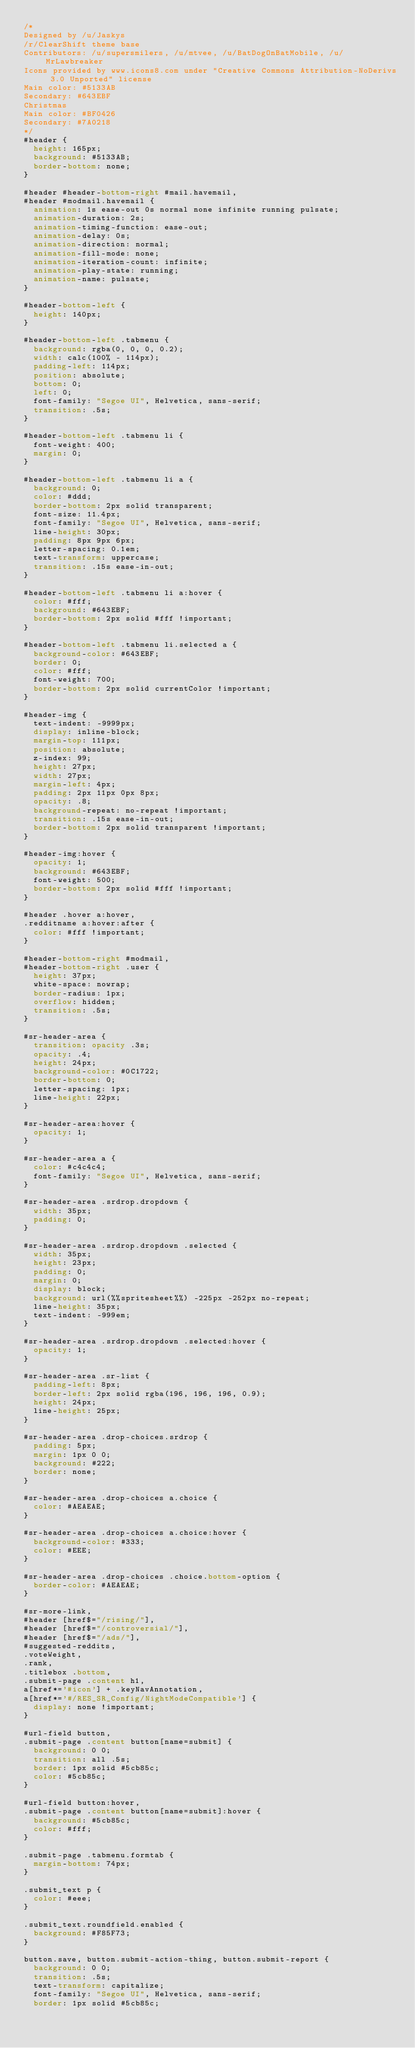Convert code to text. <code><loc_0><loc_0><loc_500><loc_500><_CSS_>/* 
Designed by /u/Jaskys
/r/ClearShift theme base
Contributors: /u/supersmilers, /u/mtvee, /u/BatDogOnBatMobile, /u/MrLawbreaker
Icons provided by www.icons8.com under "Creative Commons Attribution-NoDerivs 3.0 Unported" license
Main color: #5133AB
Secondary: #643EBF
Christmas
Main color: #BF0426
Secondary: #7A0218
*/
#header {
  height: 165px;
  background: #5133AB;
  border-bottom: none;
}

#header #header-bottom-right #mail.havemail,
#header #modmail.havemail {
  animation: 1s ease-out 0s normal none infinite running pulsate;
  animation-duration: 2s;
  animation-timing-function: ease-out;
  animation-delay: 0s;
  animation-direction: normal;
  animation-fill-mode: none;
  animation-iteration-count: infinite;
  animation-play-state: running;
  animation-name: pulsate;
}

#header-bottom-left {
  height: 140px;
}

#header-bottom-left .tabmenu {
  background: rgba(0, 0, 0, 0.2);
  width: calc(100% - 114px);
  padding-left: 114px;
  position: absolute;
  bottom: 0;
  left: 0;
  font-family: "Segoe UI", Helvetica, sans-serif;
  transition: .5s;
}

#header-bottom-left .tabmenu li {
  font-weight: 400;
  margin: 0;
}

#header-bottom-left .tabmenu li a {
  background: 0;
  color: #ddd;
  border-bottom: 2px solid transparent;
  font-size: 11.4px;
  font-family: "Segoe UI", Helvetica, sans-serif;
  line-height: 30px;
  padding: 8px 9px 6px;
  letter-spacing: 0.1em;
  text-transform: uppercase;
  transition: .15s ease-in-out;
}

#header-bottom-left .tabmenu li a:hover {
  color: #fff;
  background: #643EBF;
  border-bottom: 2px solid #fff !important;
}

#header-bottom-left .tabmenu li.selected a {
  background-color: #643EBF;
  border: 0;
  color: #fff;
  font-weight: 700;
  border-bottom: 2px solid currentColor !important;
}

#header-img {
  text-indent: -9999px;
  display: inline-block;
  margin-top: 111px;
  position: absolute;
  z-index: 99;
  height: 27px;
  width: 27px;
  margin-left: 4px;
  padding: 2px 11px 0px 8px;
  opacity: .8;
  background-repeat: no-repeat !important;
  transition: .15s ease-in-out;
  border-bottom: 2px solid transparent !important;
}

#header-img:hover {
  opacity: 1;
  background: #643EBF;
  font-weight: 500;
  border-bottom: 2px solid #fff !important;
}

#header .hover a:hover,
.redditname a:hover:after {
  color: #fff !important;
}

#header-bottom-right #modmail,
#header-bottom-right .user {
  height: 37px;
  white-space: nowrap;
  border-radius: 1px;
  overflow: hidden;
  transition: .5s;
}

#sr-header-area {
  transition: opacity .3s;
  opacity: .4;
  height: 24px;
  background-color: #0C1722;
  border-bottom: 0;
  letter-spacing: 1px;
  line-height: 22px;
}

#sr-header-area:hover {
  opacity: 1;
}

#sr-header-area a {
  color: #c4c4c4;
  font-family: "Segoe UI", Helvetica, sans-serif;
}

#sr-header-area .srdrop.dropdown {
  width: 35px;
  padding: 0;
}

#sr-header-area .srdrop.dropdown .selected {
  width: 35px;
  height: 23px;
  padding: 0;
  margin: 0;
  display: block;
  background: url(%%spritesheet%%) -225px -252px no-repeat;
  line-height: 35px;
  text-indent: -999em;
}

#sr-header-area .srdrop.dropdown .selected:hover {
  opacity: 1;
}

#sr-header-area .sr-list {
  padding-left: 8px;
  border-left: 2px solid rgba(196, 196, 196, 0.9);
  height: 24px;
  line-height: 25px;
}

#sr-header-area .drop-choices.srdrop {
  padding: 5px;
  margin: 1px 0 0;
  background: #222;
  border: none;
}

#sr-header-area .drop-choices a.choice {
  color: #AEAEAE;
}

#sr-header-area .drop-choices a.choice:hover {
  background-color: #333;
  color: #EEE;
}

#sr-header-area .drop-choices .choice.bottom-option {
  border-color: #AEAEAE;
}

#sr-more-link,
#header [href$="/rising/"],
#header [href$="/controversial/"],
#header [href$="/ads/"],
#suggested-reddits,
.voteWeight,
.rank,
.titlebox .bottom,
.submit-page .content h1,
a[href*='#icon'] + .keyNavAnnotation,
a[href*='#/RES_SR_Config/NightModeCompatible'] {
  display: none !important;
}

#url-field button,
.submit-page .content button[name=submit] {
  background: 0 0;
  transition: all .5s;
  border: 1px solid #5cb85c;
  color: #5cb85c;
}

#url-field button:hover,
.submit-page .content button[name=submit]:hover {
  background: #5cb85c;
  color: #fff;
}

.submit-page .tabmenu.formtab {
  margin-bottom: 74px;
}

.submit_text p {
  color: #eee;
}

.submit_text.roundfield.enabled {
  background: #F85F73;
}

button.save, button.submit-action-thing, button.submit-report {
  background: 0 0;
  transition: .5s;
  text-transform: capitalize;
  font-family: "Segoe UI", Helvetica, sans-serif;
  border: 1px solid #5cb85c;</code> 